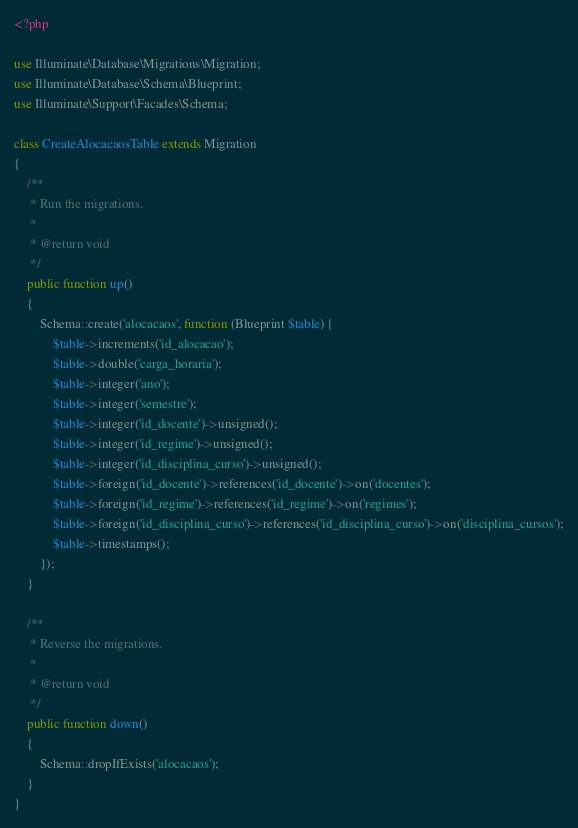<code> <loc_0><loc_0><loc_500><loc_500><_PHP_><?php

use Illuminate\Database\Migrations\Migration;
use Illuminate\Database\Schema\Blueprint;
use Illuminate\Support\Facades\Schema;

class CreateAlocacaosTable extends Migration
{
    /**
     * Run the migrations.
     *
     * @return void
     */
    public function up()
    {
        Schema::create('alocacaos', function (Blueprint $table) {
            $table->increments('id_alocacao');
            $table->double('carga_horaria');
            $table->integer('ano');
            $table->integer('semestre');
            $table->integer('id_docente')->unsigned();
            $table->integer('id_regime')->unsigned();
            $table->integer('id_disciplina_curso')->unsigned();
            $table->foreign('id_docente')->references('id_docente')->on('docentes');
            $table->foreign('id_regime')->references('id_regime')->on('regimes');
            $table->foreign('id_disciplina_curso')->references('id_disciplina_curso')->on('disciplina_cursos');
            $table->timestamps();
        });
    }

    /**
     * Reverse the migrations.
     *
     * @return void
     */
    public function down()
    {
        Schema::dropIfExists('alocacaos');
    }
}
</code> 